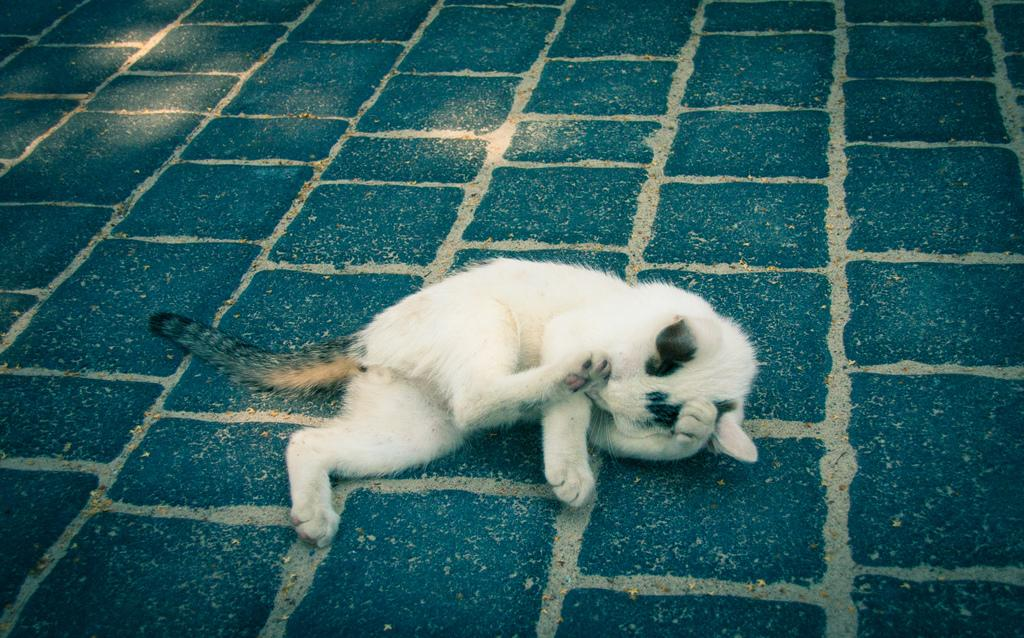What type of animal is present in the image? There is a cat in the image. What is the cat doing in the image? The cat is lying on the floor. How many toes can be seen on the cat's paws in the image? The number of toes on the cat's paws cannot be determined from the image, as the toes are not visible. What type of sport is being played in the image? There is no sport, such as volleyball, being played in the image; it only features a cat lying on the floor. 